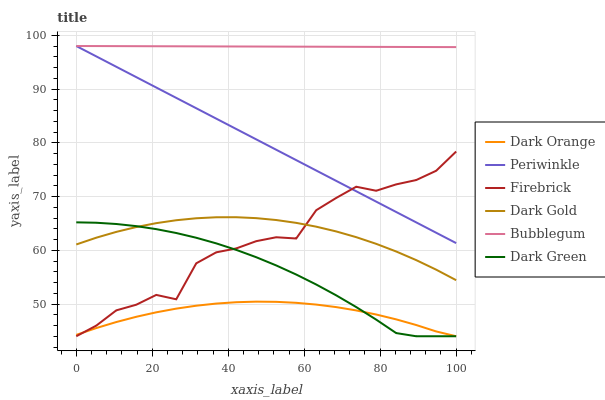Does Dark Orange have the minimum area under the curve?
Answer yes or no. Yes. Does Bubblegum have the maximum area under the curve?
Answer yes or no. Yes. Does Dark Gold have the minimum area under the curve?
Answer yes or no. No. Does Dark Gold have the maximum area under the curve?
Answer yes or no. No. Is Bubblegum the smoothest?
Answer yes or no. Yes. Is Firebrick the roughest?
Answer yes or no. Yes. Is Dark Gold the smoothest?
Answer yes or no. No. Is Dark Gold the roughest?
Answer yes or no. No. Does Dark Orange have the lowest value?
Answer yes or no. Yes. Does Dark Gold have the lowest value?
Answer yes or no. No. Does Periwinkle have the highest value?
Answer yes or no. Yes. Does Dark Gold have the highest value?
Answer yes or no. No. Is Dark Gold less than Bubblegum?
Answer yes or no. Yes. Is Periwinkle greater than Dark Green?
Answer yes or no. Yes. Does Periwinkle intersect Firebrick?
Answer yes or no. Yes. Is Periwinkle less than Firebrick?
Answer yes or no. No. Is Periwinkle greater than Firebrick?
Answer yes or no. No. Does Dark Gold intersect Bubblegum?
Answer yes or no. No. 